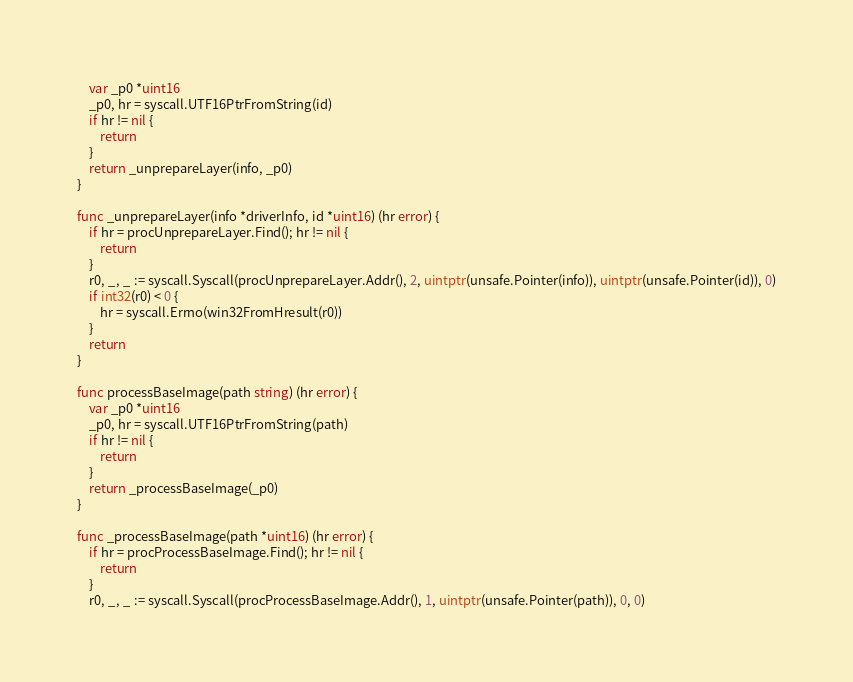<code> <loc_0><loc_0><loc_500><loc_500><_Go_>	var _p0 *uint16
	_p0, hr = syscall.UTF16PtrFromString(id)
	if hr != nil {
		return
	}
	return _unprepareLayer(info, _p0)
}

func _unprepareLayer(info *driverInfo, id *uint16) (hr error) {
	if hr = procUnprepareLayer.Find(); hr != nil {
		return
	}
	r0, _, _ := syscall.Syscall(procUnprepareLayer.Addr(), 2, uintptr(unsafe.Pointer(info)), uintptr(unsafe.Pointer(id)), 0)
	if int32(r0) < 0 {
		hr = syscall.Errno(win32FromHresult(r0))
	}
	return
}

func processBaseImage(path string) (hr error) {
	var _p0 *uint16
	_p0, hr = syscall.UTF16PtrFromString(path)
	if hr != nil {
		return
	}
	return _processBaseImage(_p0)
}

func _processBaseImage(path *uint16) (hr error) {
	if hr = procProcessBaseImage.Find(); hr != nil {
		return
	}
	r0, _, _ := syscall.Syscall(procProcessBaseImage.Addr(), 1, uintptr(unsafe.Pointer(path)), 0, 0)</code> 